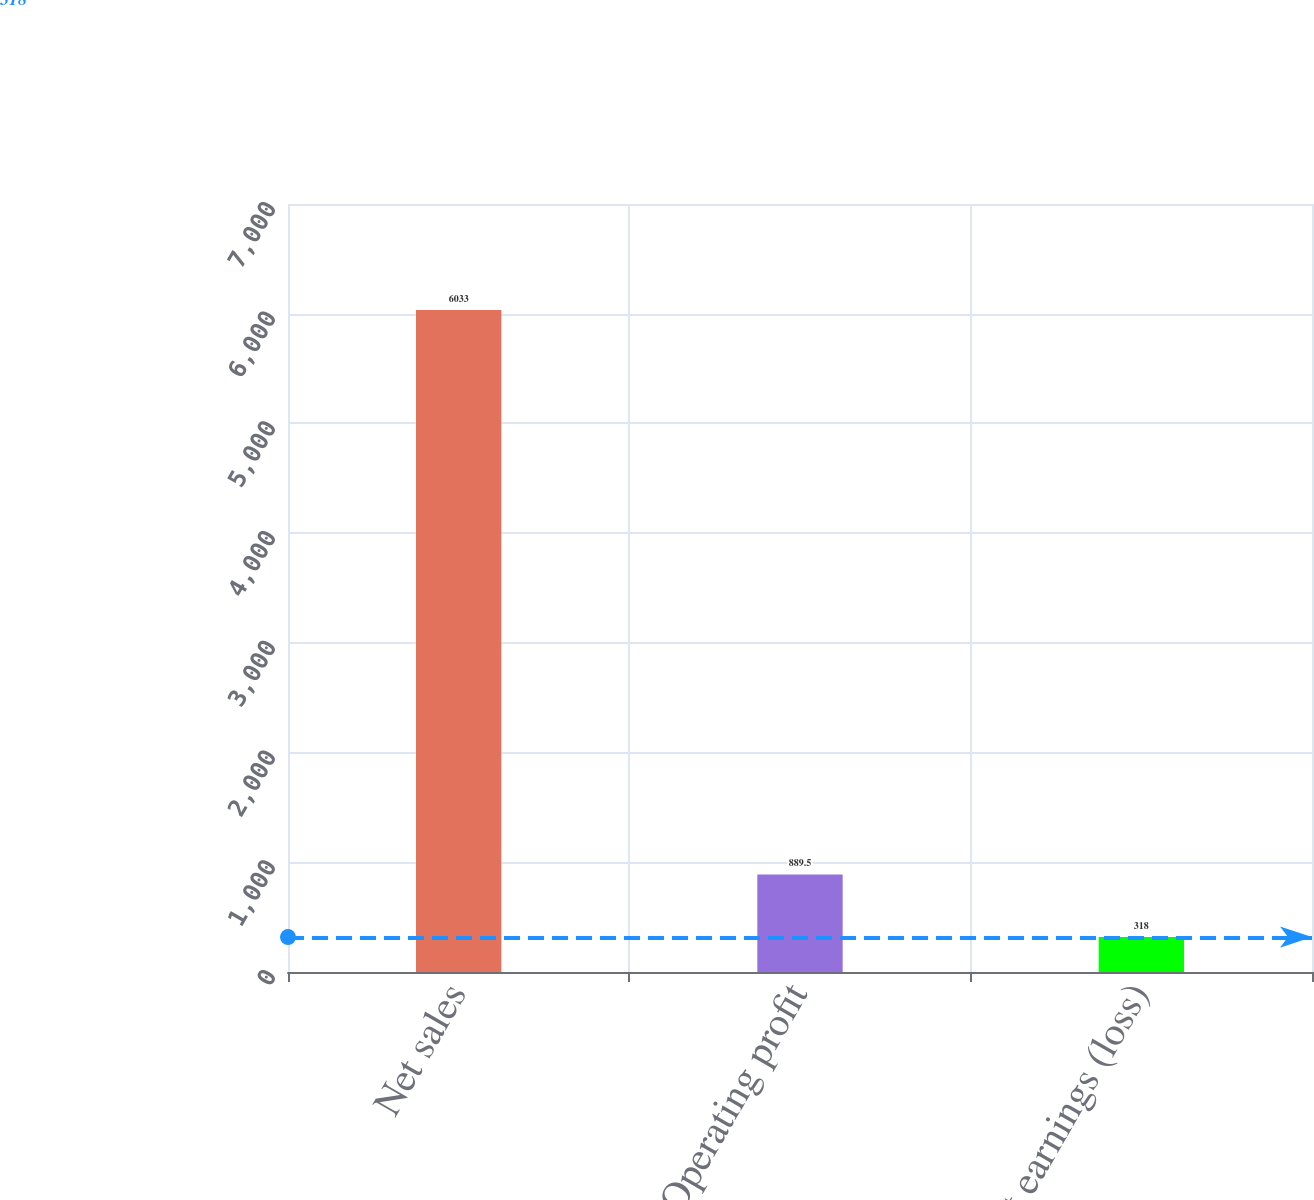<chart> <loc_0><loc_0><loc_500><loc_500><bar_chart><fcel>Net sales<fcel>Operating profit<fcel>Net earnings (loss)<nl><fcel>6033<fcel>889.5<fcel>318<nl></chart> 